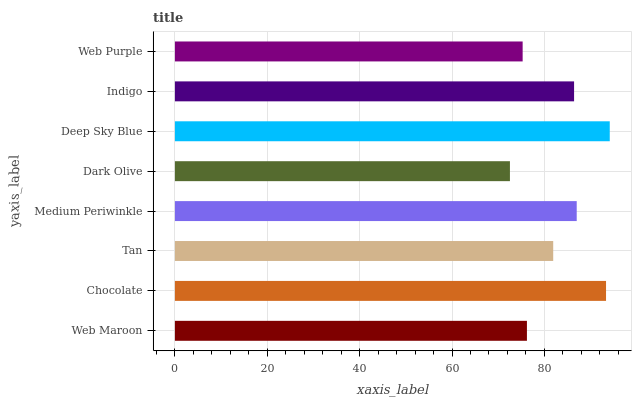Is Dark Olive the minimum?
Answer yes or no. Yes. Is Deep Sky Blue the maximum?
Answer yes or no. Yes. Is Chocolate the minimum?
Answer yes or no. No. Is Chocolate the maximum?
Answer yes or no. No. Is Chocolate greater than Web Maroon?
Answer yes or no. Yes. Is Web Maroon less than Chocolate?
Answer yes or no. Yes. Is Web Maroon greater than Chocolate?
Answer yes or no. No. Is Chocolate less than Web Maroon?
Answer yes or no. No. Is Indigo the high median?
Answer yes or no. Yes. Is Tan the low median?
Answer yes or no. Yes. Is Web Purple the high median?
Answer yes or no. No. Is Web Purple the low median?
Answer yes or no. No. 